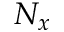<formula> <loc_0><loc_0><loc_500><loc_500>N _ { x }</formula> 